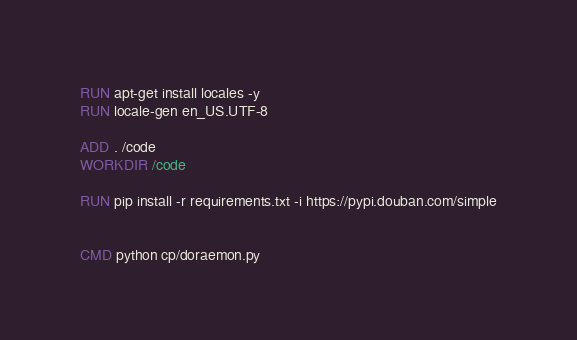Convert code to text. <code><loc_0><loc_0><loc_500><loc_500><_Dockerfile_>
RUN apt-get install locales -y
RUN locale-gen en_US.UTF-8

ADD . /code
WORKDIR /code

RUN pip install -r requirements.txt -i https://pypi.douban.com/simple


CMD python cp/doraemon.py</code> 